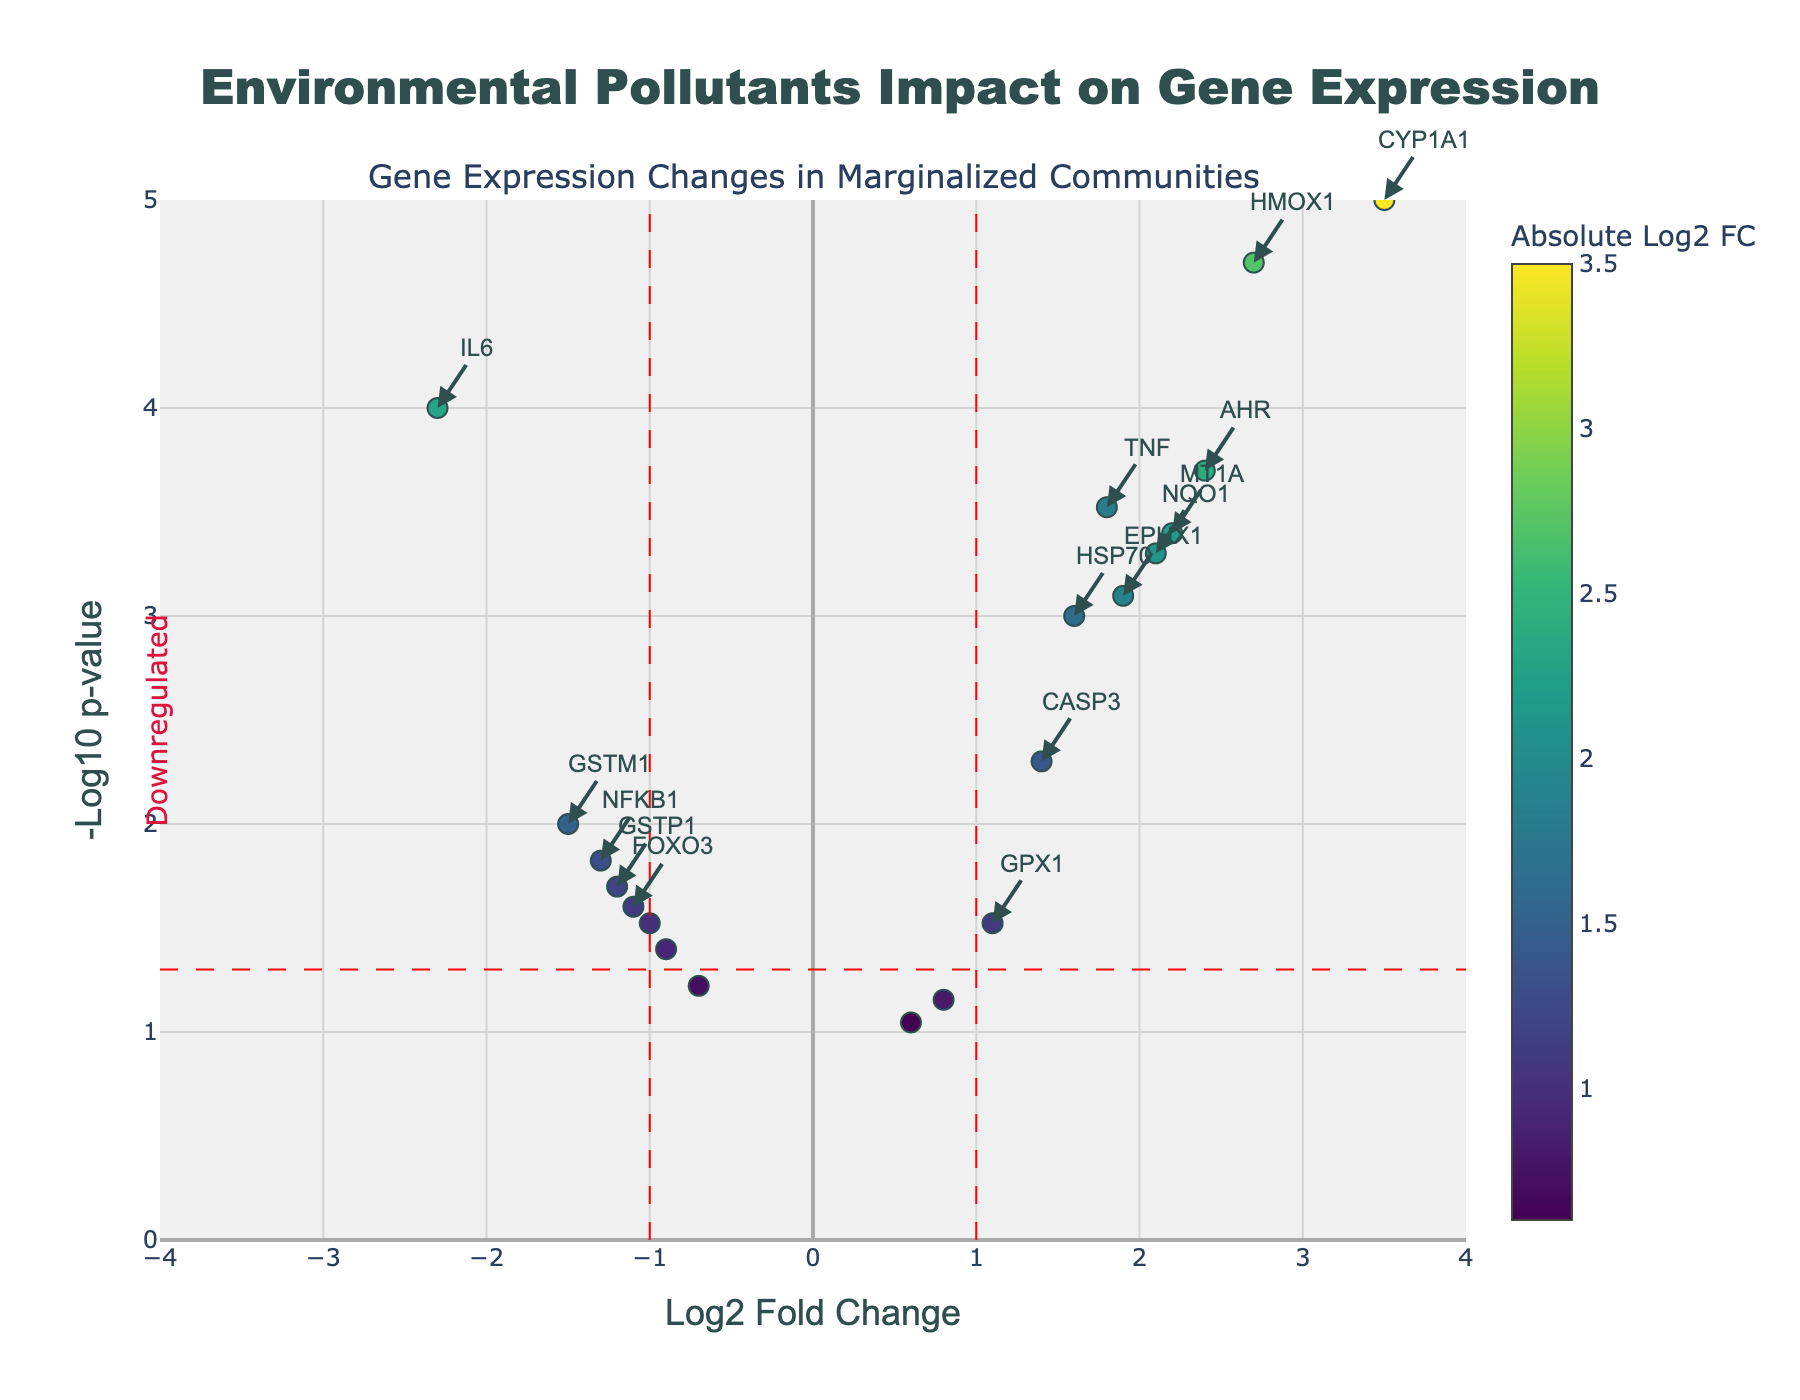What is the title of the plot? The title of the plot is displayed at the top and should be clearly visible when viewing the figure.
Answer: Environmental Pollutants Impact on Gene Expression How many genes have a Log2 Fold Change greater than 2 and are statistically significant (p-value < 0.05)? The plot shows several points above the horizontal red dashed line (representing significant p-values) and to the right of the vertical red dashed line at +1 (representing a log2 fold change greater than 1). From this, we can count the genes with Log2 Fold Change > 2 and p-value < 0.05.
Answer: 4 (CYP1A1, HMOX1, AHR, and MT1A) Which gene shows the highest upregulation? The highest upregulation can be identified by finding the data point with the highest positive Log2 Fold Change value.
Answer: CYP1A1 Which gene is the most significant among those with downregulated expression? The most significant genes have the lowest p-values, represented by the highest -log10(p-values). Among the downregulated genes, we need to find the one with the highest y-value.
Answer: IL6 What do the dashed vertical lines in the plot represent? The red dashed vertical lines indicate the thresholds for fold change. Genes beyond these lines (Log2 Fold Change > 1 or < -1) are considered significantly upregulated or downregulated.
Answer: Fold change thresholds (Log2 Fold Change > 1 or < -1) Compare the expression levels of TNF and IL6 in terms of Log2 Fold Change. Which one is higher? To compare the expression levels, find their respective Log2 Fold Change values on the x-axis and see which value is greater.
Answer: TNF What does the horizontal dashed line represent in the plot? The horizontal dashed line represents the significance threshold for the p-value (0.05). Data points above this line are considered statistically significant.
Answer: Significance p-value threshold How many genes are considered statistically significant and show downregulation? Statistically significant genes are those with p-values < 0.05 (above the horizontal red dashed line). Count the number of significant genes with negative Log2 Fold Change (left side of the plot).
Answer: 4 (IL6, GSTP1, GSTM1, and NFKB1) Among the significant genes, which ones are explicitly labeled in the plot? Significant genes are annotated with text. Those whose annotations are visible on the plot are labeled explicitly.
Answer: IL6, CYP1A1, HMOX1, TNF, NQO1, EPHX1, AHR, HSP70, MT1A, CASP3 